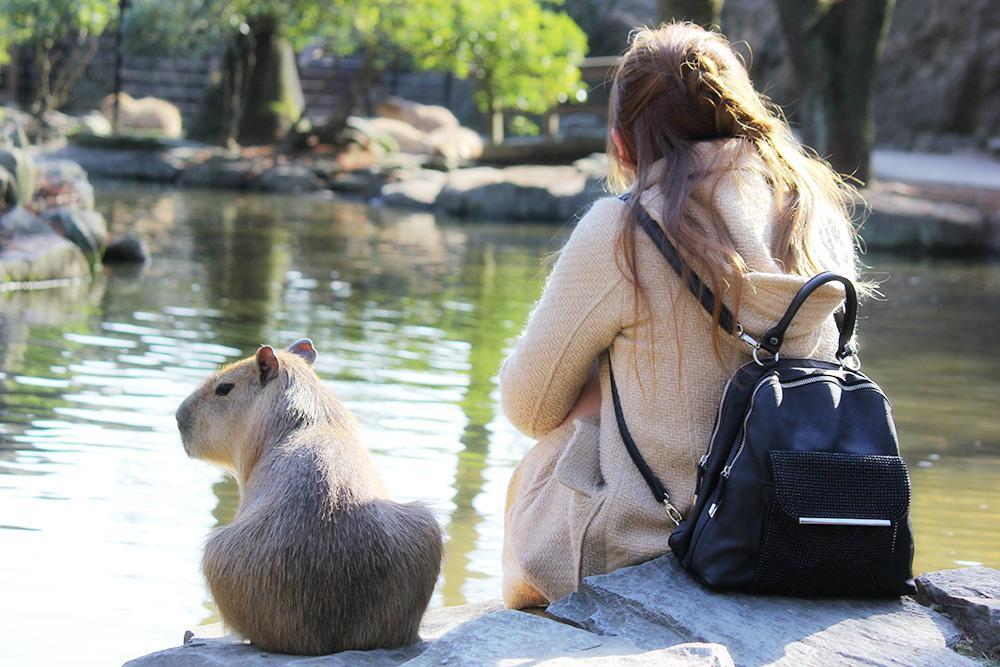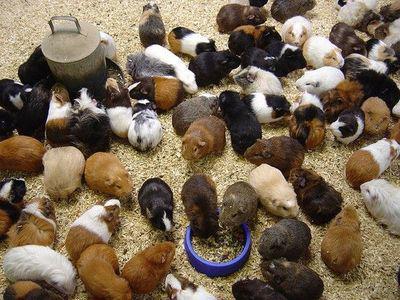The first image is the image on the left, the second image is the image on the right. Analyze the images presented: Is the assertion "There is a bowl in the image on the right." valid? Answer yes or no. Yes. 